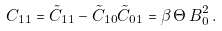<formula> <loc_0><loc_0><loc_500><loc_500>C _ { 1 1 } = \tilde { C } _ { 1 1 } - \tilde { C } _ { 1 0 } \tilde { C } _ { 0 1 } = \beta \, \Theta \, B _ { 0 } ^ { 2 } \, .</formula> 